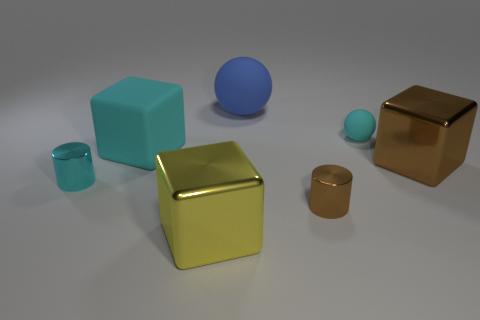Subtract all large cyan rubber cubes. How many cubes are left? 2 Subtract all cyan blocks. How many blocks are left? 2 Add 3 shiny objects. How many objects exist? 10 Subtract all blocks. How many objects are left? 4 Subtract 1 cubes. How many cubes are left? 2 Subtract all brown metallic things. Subtract all large cyan things. How many objects are left? 4 Add 7 matte things. How many matte things are left? 10 Add 3 brown cylinders. How many brown cylinders exist? 4 Subtract 1 yellow blocks. How many objects are left? 6 Subtract all red blocks. Subtract all cyan spheres. How many blocks are left? 3 